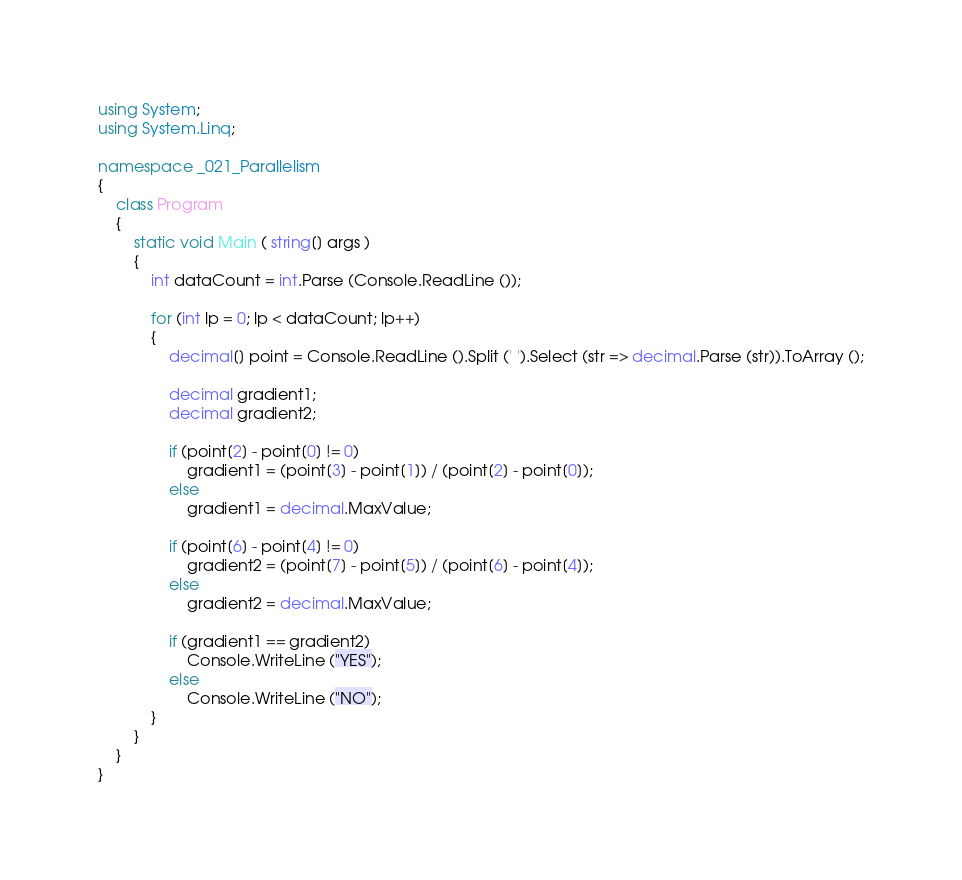<code> <loc_0><loc_0><loc_500><loc_500><_C#_>using System;
using System.Linq;

namespace _021_Parallelism
{
	class Program
	{
		static void Main ( string[] args )
		{
			int dataCount = int.Parse (Console.ReadLine ());

			for (int lp = 0; lp < dataCount; lp++)
			{
				decimal[] point = Console.ReadLine ().Split (' ').Select (str => decimal.Parse (str)).ToArray ();

				decimal gradient1;
				decimal gradient2;

				if (point[2] - point[0] != 0)
					gradient1 = (point[3] - point[1]) / (point[2] - point[0]);
				else
					gradient1 = decimal.MaxValue;

				if (point[6] - point[4] != 0)
					gradient2 = (point[7] - point[5]) / (point[6] - point[4]);
				else
					gradient2 = decimal.MaxValue;

				if (gradient1 == gradient2)
					Console.WriteLine ("YES");
				else
					Console.WriteLine ("NO");
			}
		}
	}
}</code> 